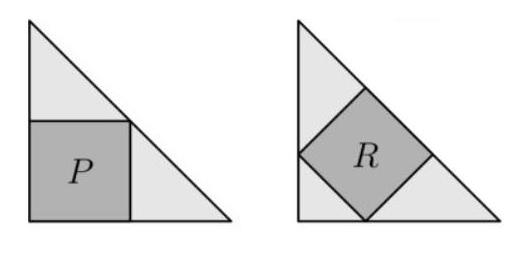What would be the proportions of the rectangle that encloses both triangles and squares? The rectangle that encloses both triangles and their interior squares would be twice as long as it is wide. This is because each triangle is an isosceles right-angled triangle, meaning its two shorter sides are of equal length. When you place two such triangles hypotenuse-to-hypotenuse to create a rectangle, the width of the rectangle is equal to the length of one of the short sides of the triangle, and the length is twice this measurement. If the shorter side is 's', then the rectangle dimensions would be 's by 2s', maintaining a 1:2 aspect ratio. 